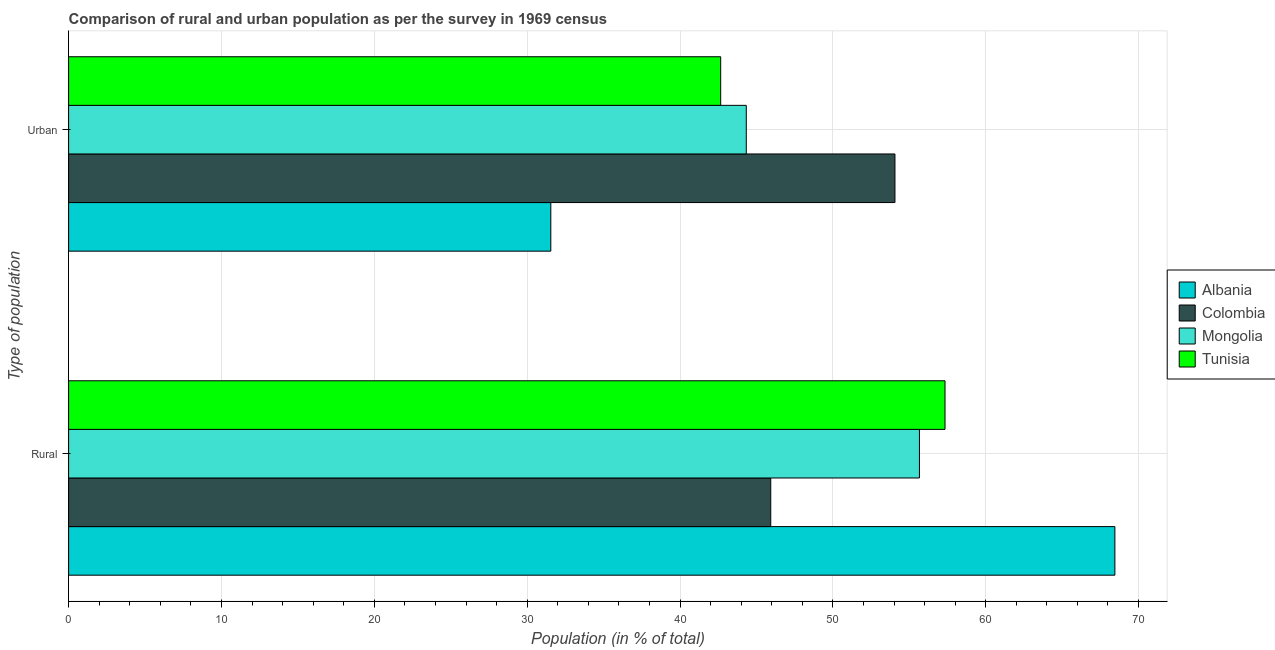How many groups of bars are there?
Your answer should be very brief. 2. Are the number of bars per tick equal to the number of legend labels?
Provide a short and direct response. Yes. How many bars are there on the 2nd tick from the top?
Your answer should be very brief. 4. What is the label of the 2nd group of bars from the top?
Your answer should be compact. Rural. What is the rural population in Mongolia?
Your answer should be very brief. 55.66. Across all countries, what is the maximum urban population?
Your answer should be very brief. 54.06. Across all countries, what is the minimum urban population?
Your response must be concise. 31.55. In which country was the urban population maximum?
Provide a succinct answer. Colombia. In which country was the urban population minimum?
Offer a terse response. Albania. What is the total rural population in the graph?
Ensure brevity in your answer.  227.39. What is the difference between the rural population in Mongolia and that in Tunisia?
Ensure brevity in your answer.  -1.67. What is the difference between the rural population in Colombia and the urban population in Tunisia?
Ensure brevity in your answer.  3.27. What is the average rural population per country?
Make the answer very short. 56.85. What is the difference between the rural population and urban population in Colombia?
Your answer should be very brief. -8.13. What is the ratio of the urban population in Colombia to that in Mongolia?
Your answer should be compact. 1.22. Is the rural population in Colombia less than that in Tunisia?
Your answer should be compact. Yes. In how many countries, is the rural population greater than the average rural population taken over all countries?
Provide a succinct answer. 2. What does the 2nd bar from the top in Urban represents?
Provide a short and direct response. Mongolia. What does the 3rd bar from the bottom in Rural represents?
Your answer should be compact. Mongolia. How many countries are there in the graph?
Offer a very short reply. 4. What is the difference between two consecutive major ticks on the X-axis?
Offer a very short reply. 10. Are the values on the major ticks of X-axis written in scientific E-notation?
Your response must be concise. No. Does the graph contain any zero values?
Make the answer very short. No. Where does the legend appear in the graph?
Offer a very short reply. Center right. How are the legend labels stacked?
Provide a succinct answer. Vertical. What is the title of the graph?
Ensure brevity in your answer.  Comparison of rural and urban population as per the survey in 1969 census. Does "Europe(all income levels)" appear as one of the legend labels in the graph?
Offer a very short reply. No. What is the label or title of the X-axis?
Your answer should be compact. Population (in % of total). What is the label or title of the Y-axis?
Make the answer very short. Type of population. What is the Population (in % of total) in Albania in Rural?
Ensure brevity in your answer.  68.45. What is the Population (in % of total) in Colombia in Rural?
Your response must be concise. 45.94. What is the Population (in % of total) of Mongolia in Rural?
Give a very brief answer. 55.66. What is the Population (in % of total) of Tunisia in Rural?
Your answer should be very brief. 57.34. What is the Population (in % of total) of Albania in Urban?
Offer a very short reply. 31.55. What is the Population (in % of total) in Colombia in Urban?
Your answer should be very brief. 54.06. What is the Population (in % of total) of Mongolia in Urban?
Provide a succinct answer. 44.34. What is the Population (in % of total) in Tunisia in Urban?
Provide a succinct answer. 42.66. Across all Type of population, what is the maximum Population (in % of total) of Albania?
Give a very brief answer. 68.45. Across all Type of population, what is the maximum Population (in % of total) in Colombia?
Give a very brief answer. 54.06. Across all Type of population, what is the maximum Population (in % of total) of Mongolia?
Provide a short and direct response. 55.66. Across all Type of population, what is the maximum Population (in % of total) of Tunisia?
Offer a very short reply. 57.34. Across all Type of population, what is the minimum Population (in % of total) in Albania?
Your answer should be compact. 31.55. Across all Type of population, what is the minimum Population (in % of total) of Colombia?
Provide a short and direct response. 45.94. Across all Type of population, what is the minimum Population (in % of total) in Mongolia?
Your answer should be compact. 44.34. Across all Type of population, what is the minimum Population (in % of total) in Tunisia?
Offer a very short reply. 42.66. What is the total Population (in % of total) of Albania in the graph?
Offer a terse response. 100. What is the difference between the Population (in % of total) in Albania in Rural and that in Urban?
Offer a terse response. 36.9. What is the difference between the Population (in % of total) in Colombia in Rural and that in Urban?
Make the answer very short. -8.13. What is the difference between the Population (in % of total) in Mongolia in Rural and that in Urban?
Keep it short and to the point. 11.33. What is the difference between the Population (in % of total) of Tunisia in Rural and that in Urban?
Offer a very short reply. 14.68. What is the difference between the Population (in % of total) in Albania in Rural and the Population (in % of total) in Colombia in Urban?
Your answer should be compact. 14.39. What is the difference between the Population (in % of total) in Albania in Rural and the Population (in % of total) in Mongolia in Urban?
Your answer should be very brief. 24.12. What is the difference between the Population (in % of total) of Albania in Rural and the Population (in % of total) of Tunisia in Urban?
Make the answer very short. 25.79. What is the difference between the Population (in % of total) of Colombia in Rural and the Population (in % of total) of Mongolia in Urban?
Make the answer very short. 1.6. What is the difference between the Population (in % of total) in Colombia in Rural and the Population (in % of total) in Tunisia in Urban?
Your response must be concise. 3.27. What is the difference between the Population (in % of total) of Mongolia in Rural and the Population (in % of total) of Tunisia in Urban?
Your response must be concise. 13. What is the average Population (in % of total) of Colombia per Type of population?
Give a very brief answer. 50. What is the difference between the Population (in % of total) in Albania and Population (in % of total) in Colombia in Rural?
Offer a terse response. 22.52. What is the difference between the Population (in % of total) in Albania and Population (in % of total) in Mongolia in Rural?
Your answer should be compact. 12.79. What is the difference between the Population (in % of total) in Albania and Population (in % of total) in Tunisia in Rural?
Your answer should be compact. 11.11. What is the difference between the Population (in % of total) in Colombia and Population (in % of total) in Mongolia in Rural?
Give a very brief answer. -9.73. What is the difference between the Population (in % of total) of Colombia and Population (in % of total) of Tunisia in Rural?
Offer a terse response. -11.4. What is the difference between the Population (in % of total) in Mongolia and Population (in % of total) in Tunisia in Rural?
Make the answer very short. -1.67. What is the difference between the Population (in % of total) of Albania and Population (in % of total) of Colombia in Urban?
Your answer should be compact. -22.52. What is the difference between the Population (in % of total) of Albania and Population (in % of total) of Mongolia in Urban?
Your response must be concise. -12.79. What is the difference between the Population (in % of total) of Albania and Population (in % of total) of Tunisia in Urban?
Your answer should be compact. -11.11. What is the difference between the Population (in % of total) of Colombia and Population (in % of total) of Mongolia in Urban?
Your answer should be compact. 9.73. What is the difference between the Population (in % of total) in Colombia and Population (in % of total) in Tunisia in Urban?
Provide a short and direct response. 11.4. What is the difference between the Population (in % of total) in Mongolia and Population (in % of total) in Tunisia in Urban?
Ensure brevity in your answer.  1.67. What is the ratio of the Population (in % of total) of Albania in Rural to that in Urban?
Provide a short and direct response. 2.17. What is the ratio of the Population (in % of total) in Colombia in Rural to that in Urban?
Provide a short and direct response. 0.85. What is the ratio of the Population (in % of total) of Mongolia in Rural to that in Urban?
Offer a terse response. 1.26. What is the ratio of the Population (in % of total) in Tunisia in Rural to that in Urban?
Offer a terse response. 1.34. What is the difference between the highest and the second highest Population (in % of total) of Albania?
Keep it short and to the point. 36.9. What is the difference between the highest and the second highest Population (in % of total) of Colombia?
Make the answer very short. 8.13. What is the difference between the highest and the second highest Population (in % of total) of Mongolia?
Give a very brief answer. 11.33. What is the difference between the highest and the second highest Population (in % of total) of Tunisia?
Offer a very short reply. 14.68. What is the difference between the highest and the lowest Population (in % of total) of Albania?
Your answer should be compact. 36.9. What is the difference between the highest and the lowest Population (in % of total) of Colombia?
Your answer should be compact. 8.13. What is the difference between the highest and the lowest Population (in % of total) of Mongolia?
Keep it short and to the point. 11.33. What is the difference between the highest and the lowest Population (in % of total) in Tunisia?
Give a very brief answer. 14.68. 